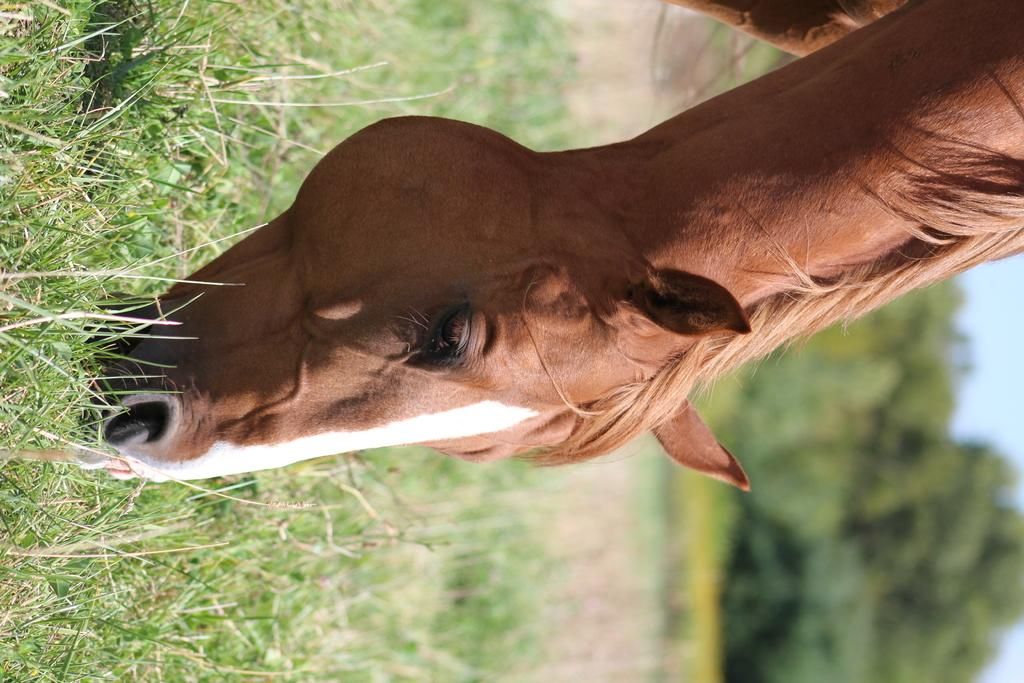What animal is present in the image? There is a horse in the image. What type of terrain is visible in the image? The land is grassy. What can be seen on the right side of the image? There are trees on the right side of the image. How many apples are hanging from the trees on the right side of the image? There are no apples visible in the image; only trees are present on the right side. 